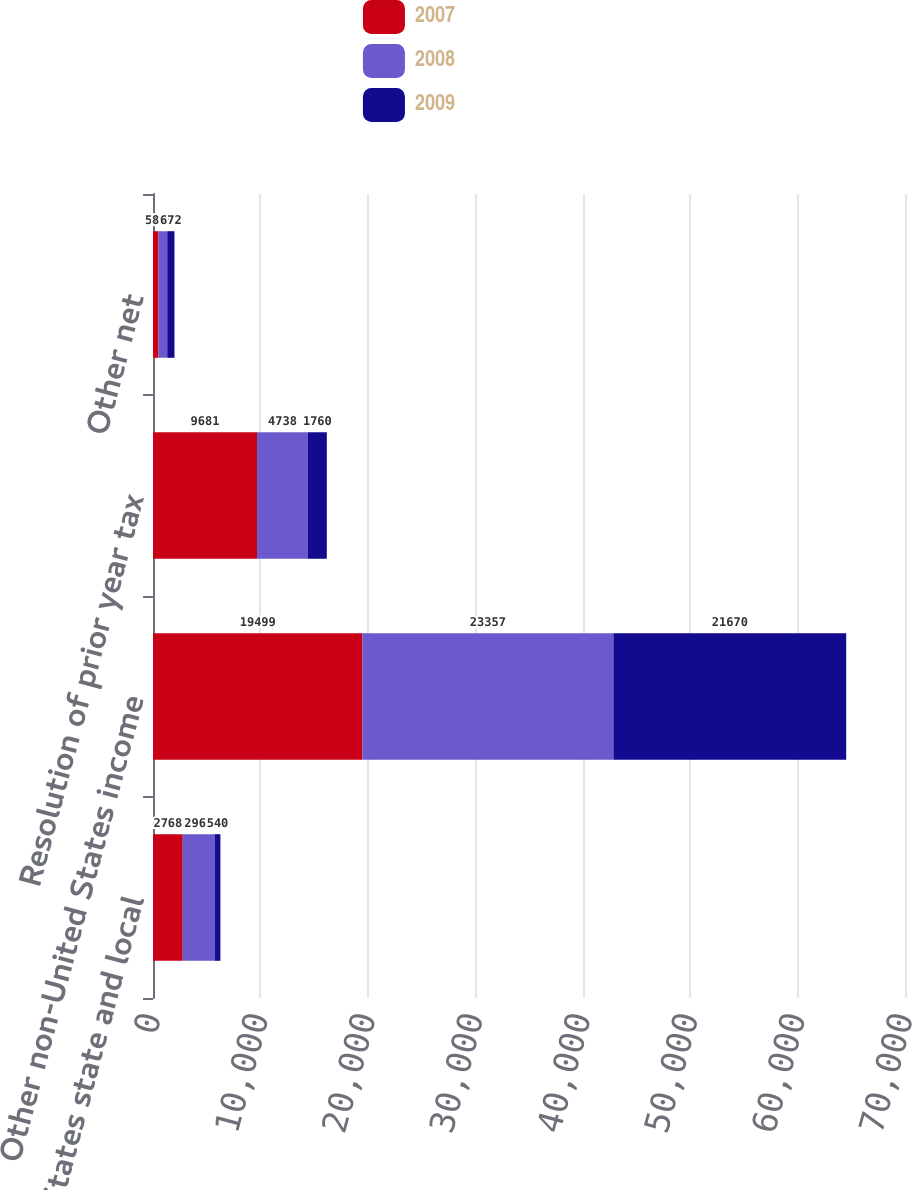<chart> <loc_0><loc_0><loc_500><loc_500><stacked_bar_chart><ecel><fcel>United States state and local<fcel>Other non-United States income<fcel>Resolution of prior year tax<fcel>Other net<nl><fcel>2007<fcel>2768<fcel>19499<fcel>9681<fcel>512<nl><fcel>2008<fcel>2966<fcel>23357<fcel>4738<fcel>815<nl><fcel>2009<fcel>540<fcel>21670<fcel>1760<fcel>672<nl></chart> 